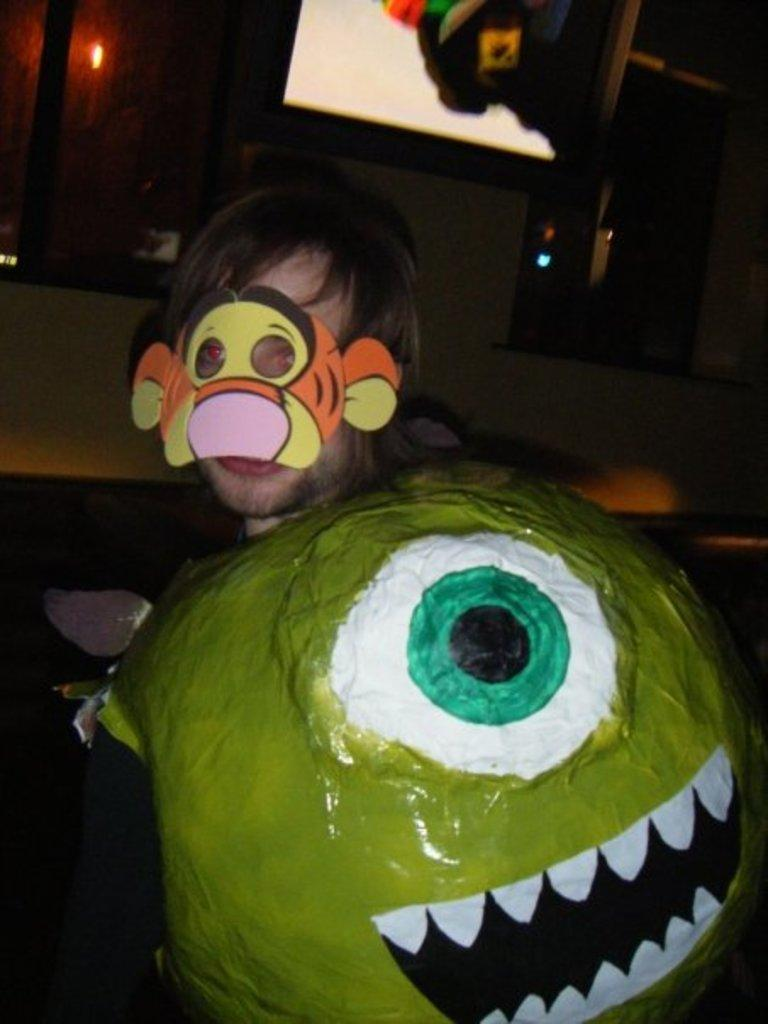Who or what is present in the image? There is a person in the image. What is the person wearing on their face? The person is wearing a mask on their face. What can be seen behind the person? There are glass windows in front of the person. What electronic device is visible at the top of the image? There is a television at the top of the image. What type of kettle is boiling on the wall in the image? There is no kettle present in the image, and the wall is not mentioned in the provided facts. How many pies are visible on the person's face in the image? The person is wearing a mask on their face, and there are no pies visible in the image. 